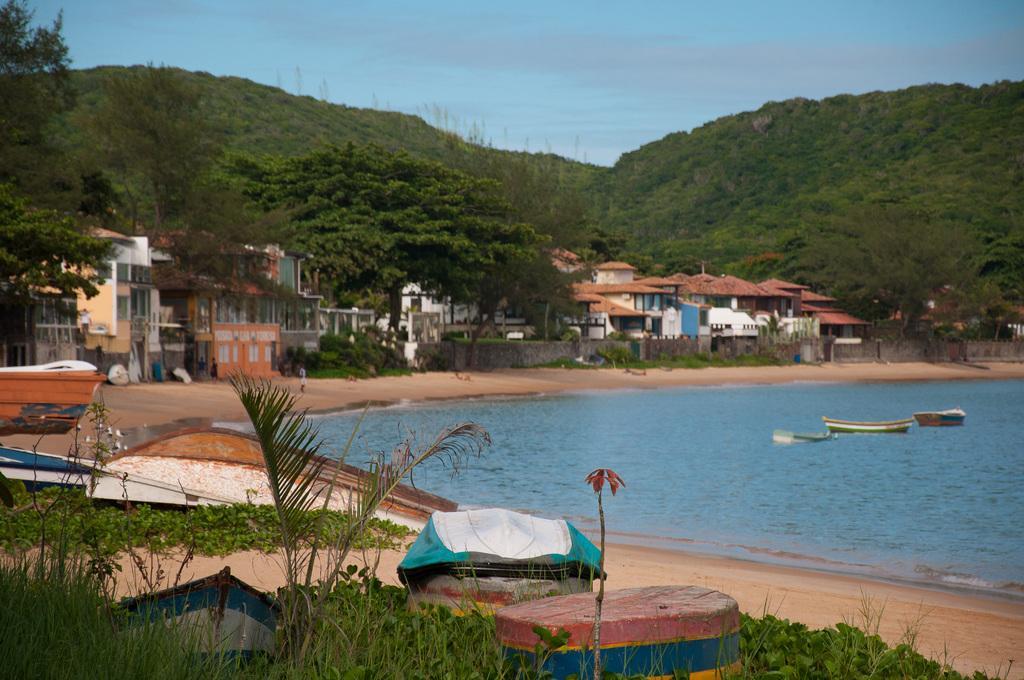In one or two sentences, can you explain what this image depicts? In this image we can see sky with clouds, buildings, walls, bushes, road, boats on the seashore and boats on the water. 